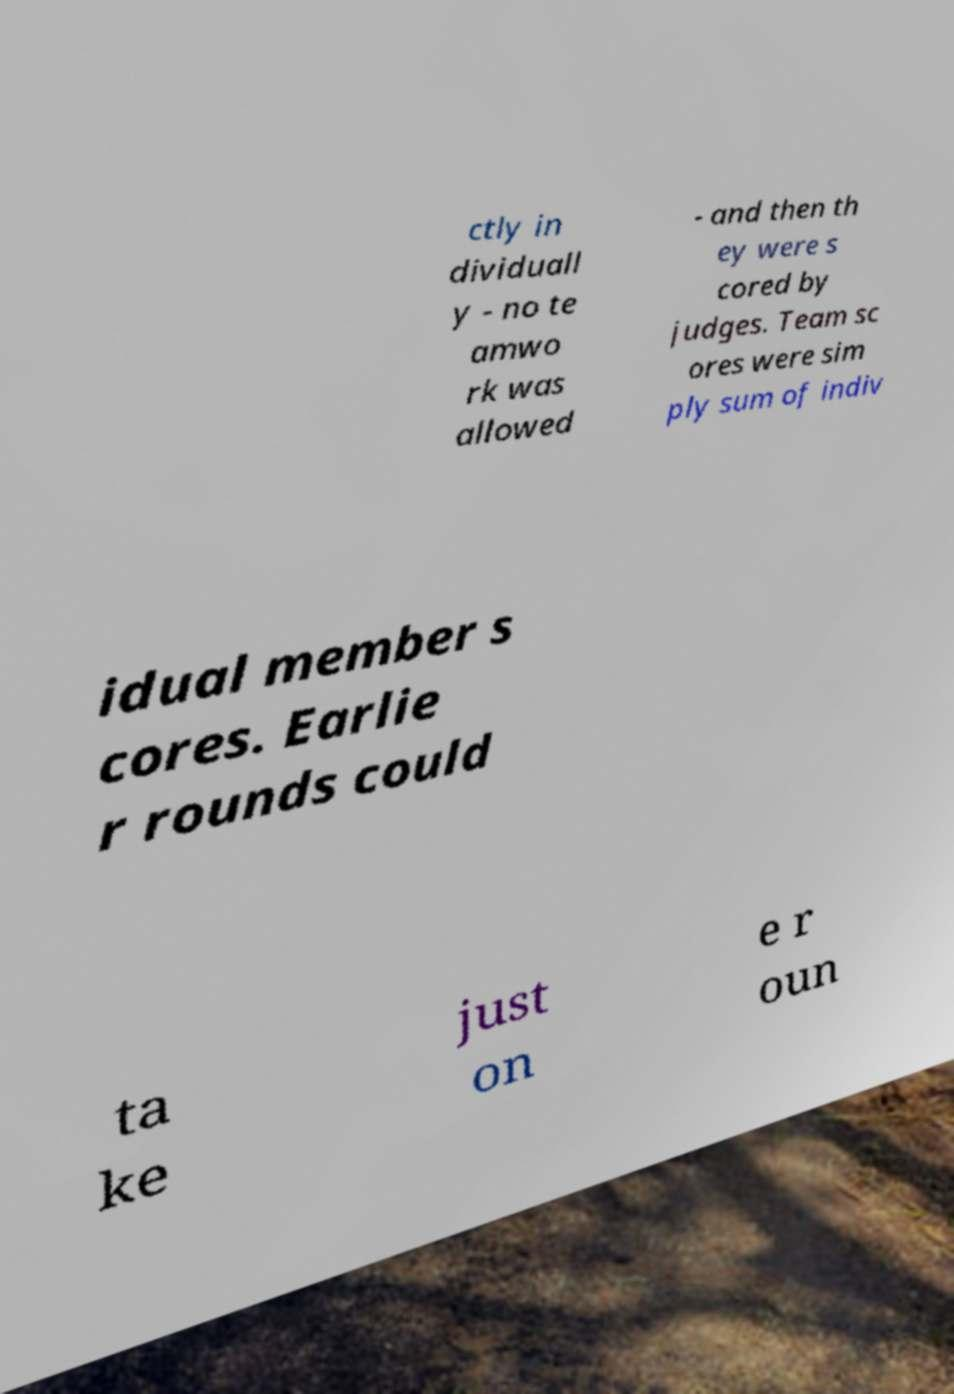Can you read and provide the text displayed in the image?This photo seems to have some interesting text. Can you extract and type it out for me? ctly in dividuall y - no te amwo rk was allowed - and then th ey were s cored by judges. Team sc ores were sim ply sum of indiv idual member s cores. Earlie r rounds could ta ke just on e r oun 